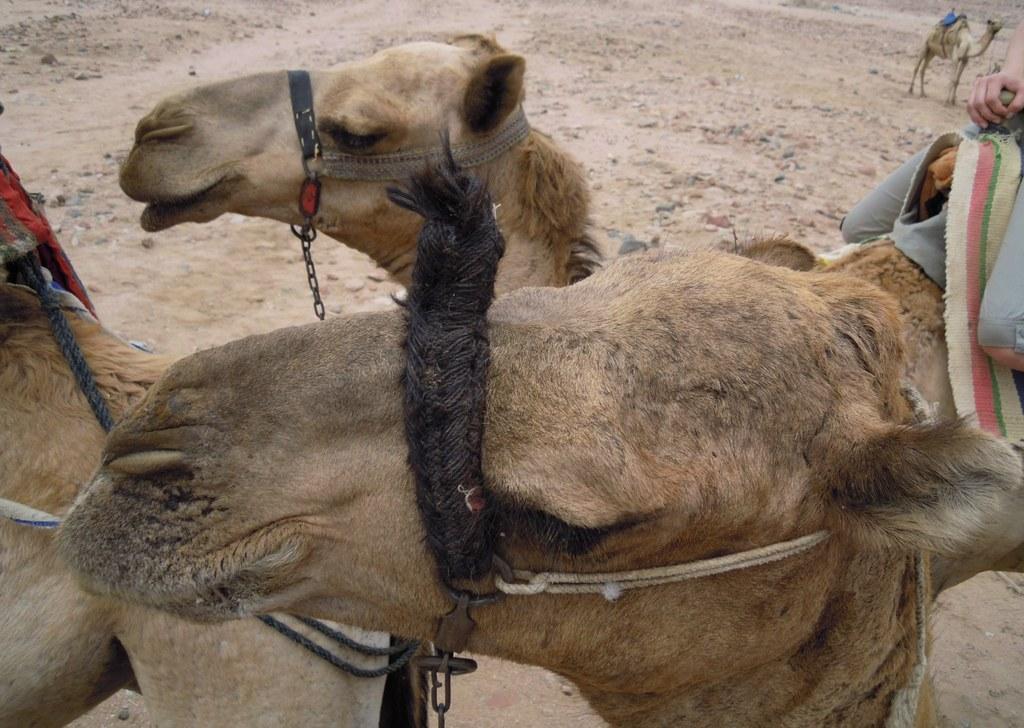Could you give a brief overview of what you see in this image? These are the camels and this is sand. 